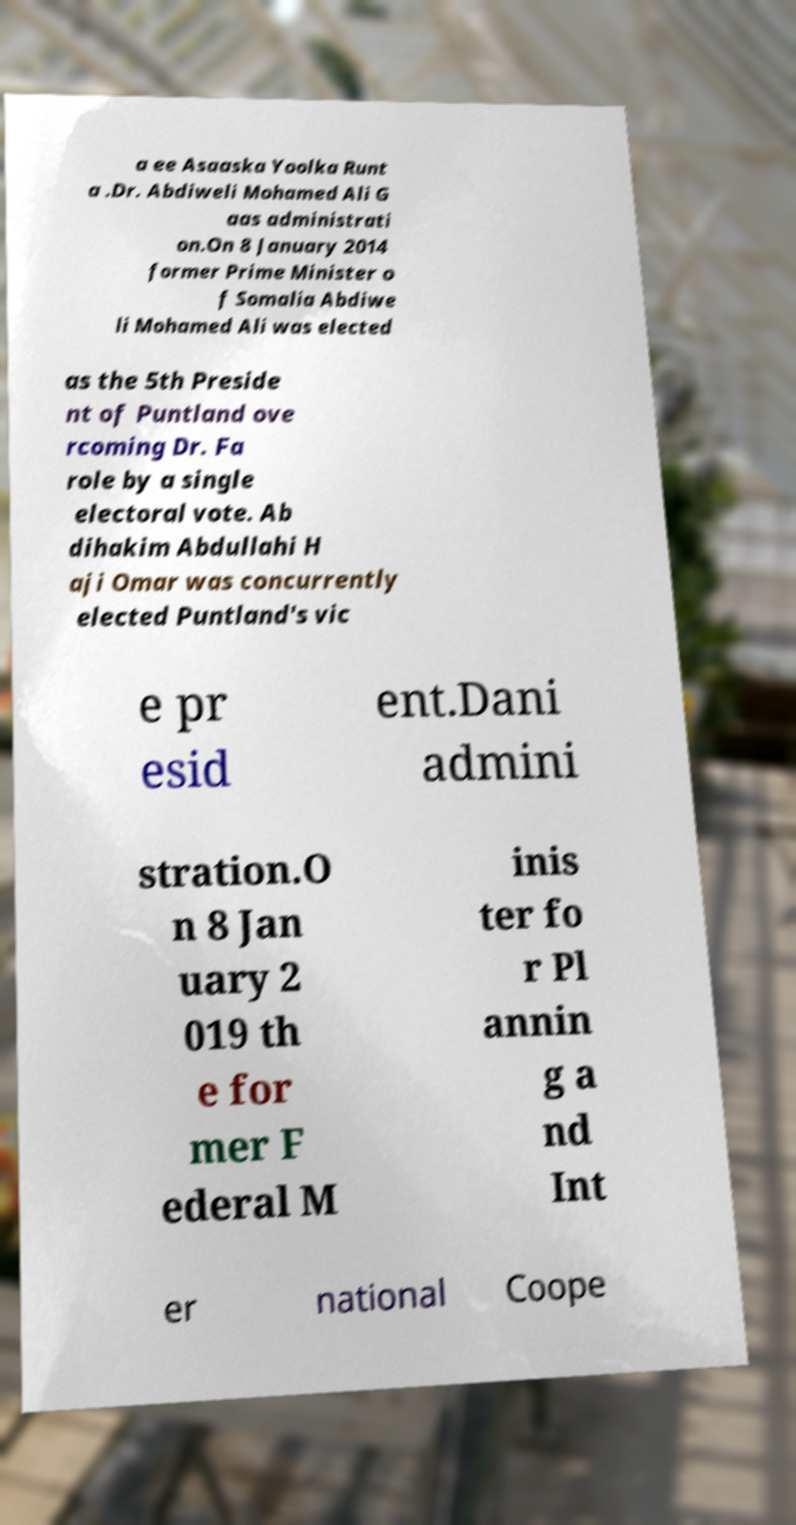Can you accurately transcribe the text from the provided image for me? a ee Asaaska Yoolka Runt a .Dr. Abdiweli Mohamed Ali G aas administrati on.On 8 January 2014 former Prime Minister o f Somalia Abdiwe li Mohamed Ali was elected as the 5th Preside nt of Puntland ove rcoming Dr. Fa role by a single electoral vote. Ab dihakim Abdullahi H aji Omar was concurrently elected Puntland's vic e pr esid ent.Dani admini stration.O n 8 Jan uary 2 019 th e for mer F ederal M inis ter fo r Pl annin g a nd Int er national Coope 